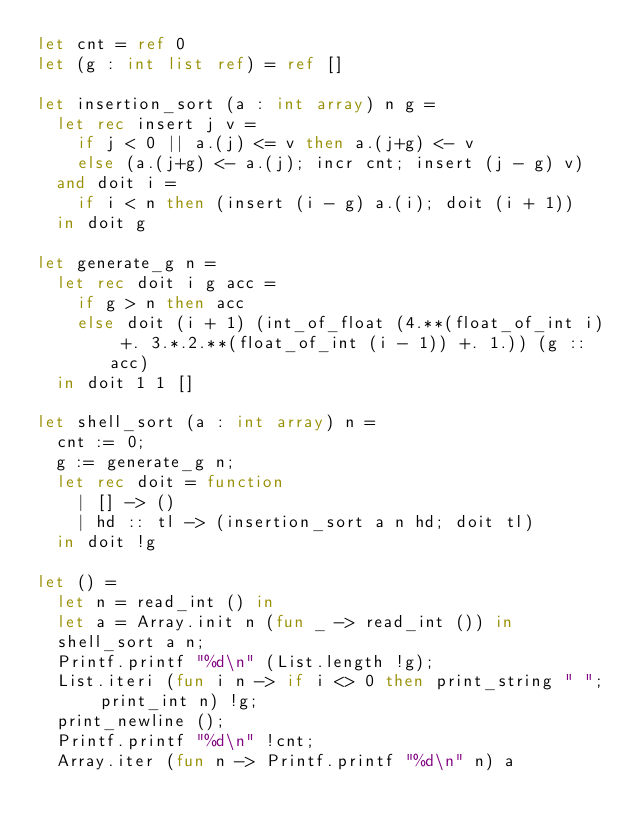<code> <loc_0><loc_0><loc_500><loc_500><_OCaml_>let cnt = ref 0 
let (g : int list ref) = ref []
  
let insertion_sort (a : int array) n g =
  let rec insert j v =
    if j < 0 || a.(j) <= v then a.(j+g) <- v
    else (a.(j+g) <- a.(j); incr cnt; insert (j - g) v)
  and doit i =
    if i < n then (insert (i - g) a.(i); doit (i + 1))
  in doit g 

let generate_g n =
  let rec doit i g acc =
    if g > n then acc
    else doit (i + 1) (int_of_float (4.**(float_of_int i) +. 3.*.2.**(float_of_int (i - 1)) +. 1.)) (g :: acc)
  in doit 1 1 []
  
let shell_sort (a : int array) n =
  cnt := 0;
  g := generate_g n;
  let rec doit = function
    | [] -> ()
    | hd :: tl -> (insertion_sort a n hd; doit tl)
  in doit !g

let () =
  let n = read_int () in
  let a = Array.init n (fun _ -> read_int ()) in
  shell_sort a n; 
  Printf.printf "%d\n" (List.length !g);
  List.iteri (fun i n -> if i <> 0 then print_string " "; print_int n) !g;
  print_newline ();
  Printf.printf "%d\n" !cnt;
  Array.iter (fun n -> Printf.printf "%d\n" n) a</code> 